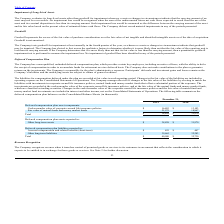From Monolithic Power Systems's financial document, What was the total deferred compensation plan asset components in 2018 and 2019 respectively? The document shows two values: 31,970 and 38,858 (in thousands). From the document: "Total $ 38,858 $ 31,970 Total $ 38,858 $ 31,970..." Also, Does the company make contributions to the non-qualified, unfunded deferred compensation plan or guarantee returns on investments? does not make contributions to the plan or guarantee returns on the investments. The document states: "r retirement on a tax deferred basis. The Company does not make contributions to the plan or guarantee returns on the investments. The Company is resp..." Also, Where can changes in the fair value of the liabilities be found? operating expense on the Consolidated Statements of Operations. The document states: "the fair value of the liabilities are included in operating expense on the Consolidated Statements of Operations. The Company manages the risk of chan..." Also, can you calculate: What was the change in Cash surrender value of corporate-owned life insurance policies from 2018 to 2019? Based on the calculation: 16,883-13,103, the result is 3780 (in thousands). This is based on the information: "alue of corporate-owned life insurance policies $ 16,883 $ 13,103 orporate-owned life insurance policies $ 16,883 $ 13,103..." The key data points involved are: 13,103, 16,883. Also, can you calculate: What was the percentage change in amount spent on other long-term liabilities from 2018 to 2019? To answer this question, I need to perform calculations using the financial data. The calculation is: (39,665-32,283)/32,283, which equals 22.87 (percentage). This is based on the information: "Other long-term liabilities 39,665 32,283 Other long-term liabilities 39,665 32,283..." The key data points involved are: 32,283, 39,665. Additionally, Which year had a higher total liability? According to the financial document, 2019. The relevant text states: "2019 2018..." 